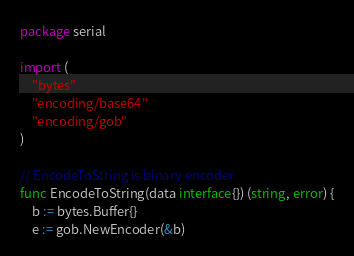Convert code to text. <code><loc_0><loc_0><loc_500><loc_500><_Go_>package serial

import (
	"bytes"
	"encoding/base64"
	"encoding/gob"
)

// EncodeToString is binary encoder
func EncodeToString(data interface{}) (string, error) {
	b := bytes.Buffer{}
	e := gob.NewEncoder(&b)</code> 